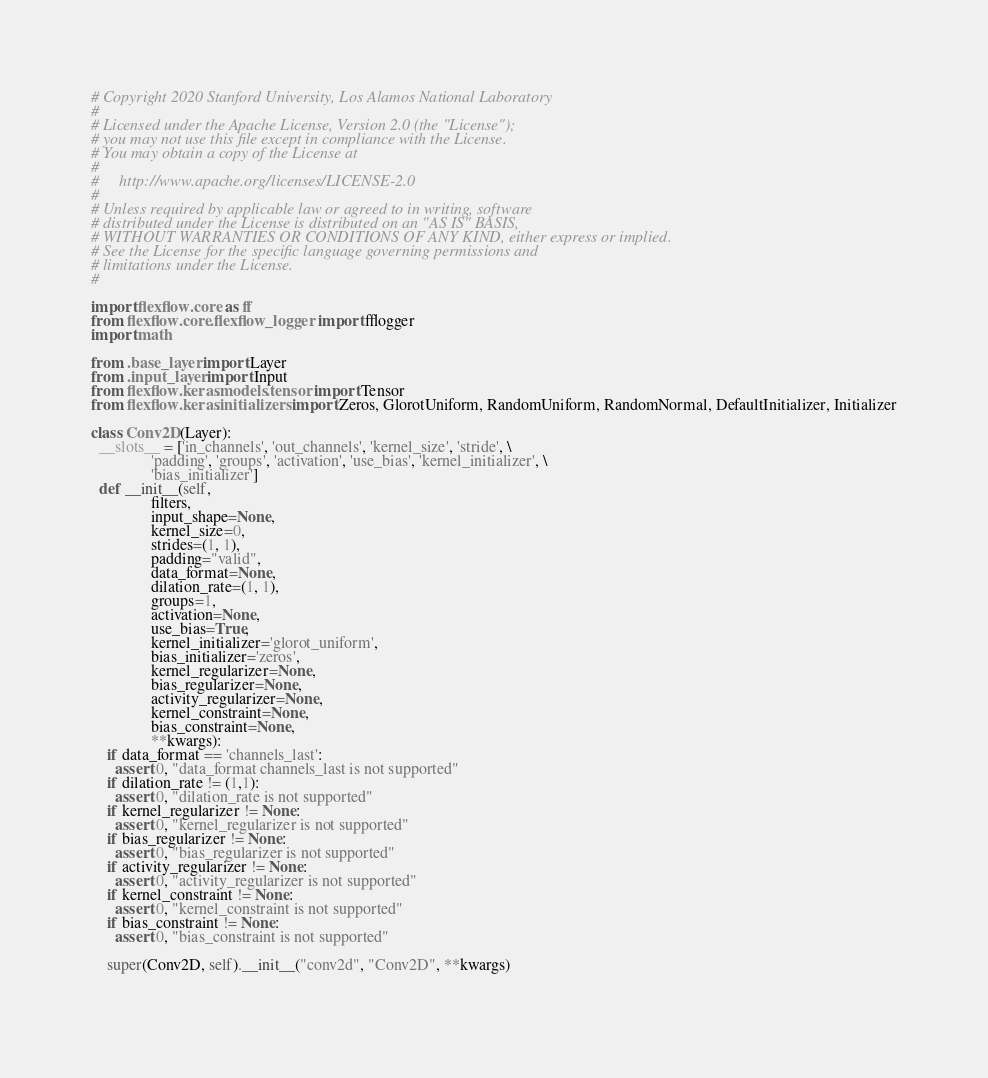<code> <loc_0><loc_0><loc_500><loc_500><_Python_># Copyright 2020 Stanford University, Los Alamos National Laboratory
#
# Licensed under the Apache License, Version 2.0 (the "License");
# you may not use this file except in compliance with the License.
# You may obtain a copy of the License at
#
#     http://www.apache.org/licenses/LICENSE-2.0
#
# Unless required by applicable law or agreed to in writing, software
# distributed under the License is distributed on an "AS IS" BASIS,
# WITHOUT WARRANTIES OR CONDITIONS OF ANY KIND, either express or implied.
# See the License for the specific language governing permissions and
# limitations under the License.
#

import flexflow.core as ff
from flexflow.core.flexflow_logger import fflogger
import math

from .base_layer import Layer
from .input_layer import Input
from flexflow.keras.models.tensor import Tensor
from flexflow.keras.initializers import Zeros, GlorotUniform, RandomUniform, RandomNormal, DefaultInitializer, Initializer

class Conv2D(Layer):
  __slots__ = ['in_channels', 'out_channels', 'kernel_size', 'stride', \
               'padding', 'groups', 'activation', 'use_bias', 'kernel_initializer', \
               'bias_initializer']
  def __init__(self, 
               filters, 
               input_shape=None, 
               kernel_size=0, 
               strides=(1, 1), 
               padding="valid", 
               data_format=None, 
               dilation_rate=(1, 1),
               groups=1, 
               activation=None, 
               use_bias=True, 
               kernel_initializer='glorot_uniform', 
               bias_initializer='zeros', 
               kernel_regularizer=None, 
               bias_regularizer=None, 
               activity_regularizer=None, 
               kernel_constraint=None, 
               bias_constraint=None, 
               **kwargs):
    if data_format == 'channels_last':
      assert 0, "data_format channels_last is not supported"
    if dilation_rate != (1,1):
      assert 0, "dilation_rate is not supported"
    if kernel_regularizer != None:
      assert 0, "kernel_regularizer is not supported"
    if bias_regularizer != None:
      assert 0, "bias_regularizer is not supported"
    if activity_regularizer != None:
      assert 0, "activity_regularizer is not supported"
    if kernel_constraint != None:
      assert 0, "kernel_constraint is not supported"
    if bias_constraint != None:
      assert 0, "bias_constraint is not supported"
    
    super(Conv2D, self).__init__("conv2d", "Conv2D", **kwargs) 
    </code> 